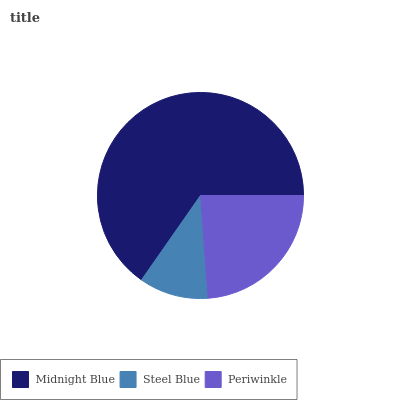Is Steel Blue the minimum?
Answer yes or no. Yes. Is Midnight Blue the maximum?
Answer yes or no. Yes. Is Periwinkle the minimum?
Answer yes or no. No. Is Periwinkle the maximum?
Answer yes or no. No. Is Periwinkle greater than Steel Blue?
Answer yes or no. Yes. Is Steel Blue less than Periwinkle?
Answer yes or no. Yes. Is Steel Blue greater than Periwinkle?
Answer yes or no. No. Is Periwinkle less than Steel Blue?
Answer yes or no. No. Is Periwinkle the high median?
Answer yes or no. Yes. Is Periwinkle the low median?
Answer yes or no. Yes. Is Steel Blue the high median?
Answer yes or no. No. Is Steel Blue the low median?
Answer yes or no. No. 